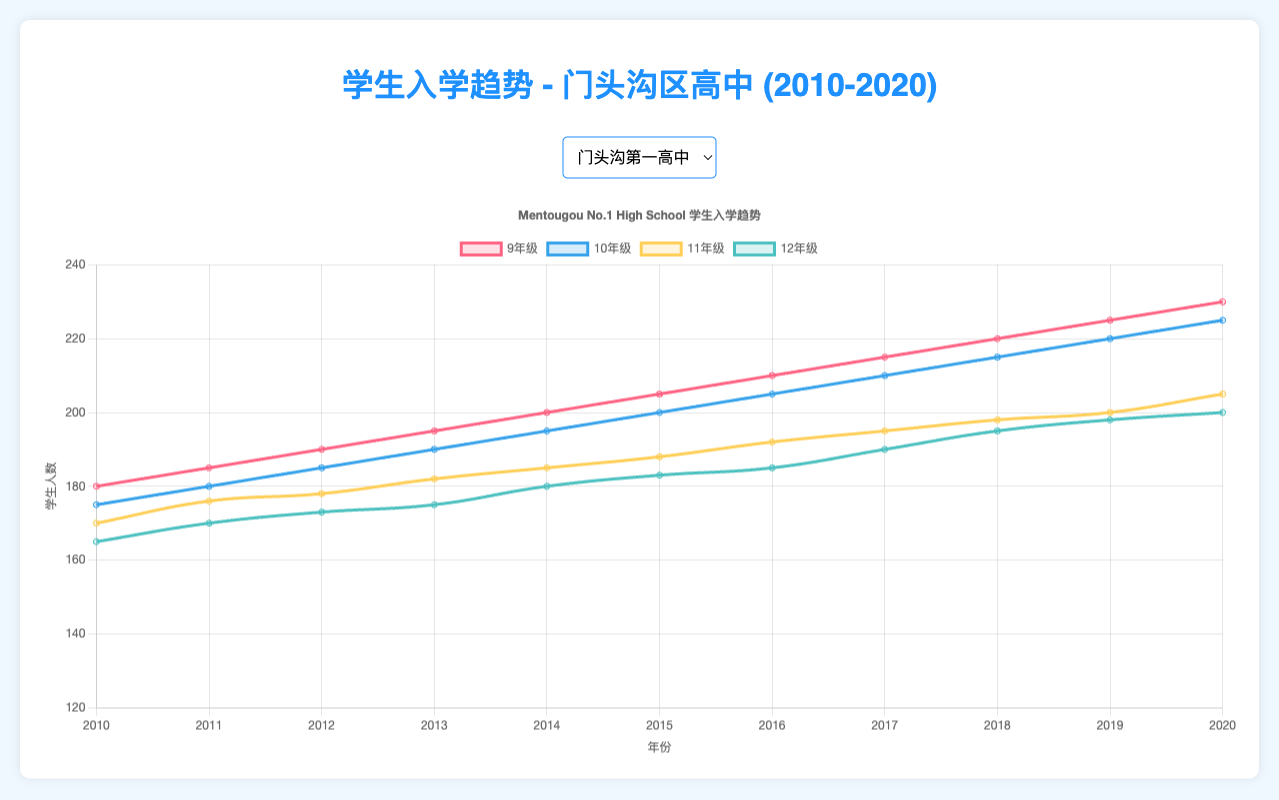What is the overall trend of 9th Grade enrollment in Mentougou No.1 High School from 2010 to 2020? The plot shows the line representing 9th Grade enrollment. The enrollment starts at 180 students in 2010 and steadily increases every year, reaching 230 students by 2020. This depicts a positive, consistent growth trend in 9th Grade enrollment over these years.
Answer: Positive growth Between Mentougou No.1 High School and Mentougou No.2 High School, which school had a higher 12th Grade enrollment in 2015? By comparing the lines for 12th Grade enrollment for both schools in 2015, Mentougou No.1 High School had 183 students, while Mentougou No.2 High School had 165 students.
Answer: Mentougou No.1 High School In which year did Mentougou Experimental High School's 11th Grade enrollment first exceed 160 students? Observing the plot, this school’s 11th Grade enrollment first exceeded 160 students in 2016 when it reached 160 and then increased further.
Answer: 2016 In 2020, what is the difference between the 9th Grade enrollment in Mentougou No.1 High School and Mentougou Experimental High School? In 2020, the two lines for 9th Grade can be compared. Mentougou No.1 High School has 230 students, and Mentougou Experimental High School has 190 students. The difference is 230 - 190 = 40 students.
Answer: 40 students What is the color used to represent the 11th Grade enrollment trend line for Mentougou No.1 High School? The color representing the 11th Grade enrollment trend for Mentougou No.1 High School is related to its line's color on the plot, which is yellow.
Answer: yellow Calculate the average 10th Grade enrollment for Mentougou No.2 High School across all years from 2010 to 2020. Summing 10th Grade enrollments from 2010 to 2020 gives: 158 + 160 + 162 + 165 + 170 + 175 + 180 + 185 + 190 + 195 + 200 = 1940. The average over these 11 years is 1940 / 11 ≈ 176.36.
Answer: 176.36 students Which grade experienced the most significant increase in enrollment numbers from 2010 to 2020 in Mentougou Experimental High School? By looking at the increase, 9th Grade enrollment went from 140 to 190, a difference of 50; 10th Grade from 138 to 185, a difference of 47; 11th Grade from 135 to 180, a difference of 45; and 12th Grade from 130 to 175, a difference of 45. The 9th Grade saw the most significant increase.
Answer: 9th Grade How did the 12th Grade enrollment trend for Mentougou No.2 High School compare to Mentougou Experimental High School from 2016 to 2020? Both trends need to be compared annually. Mentougou No.2's 12th Grade enrollment was 168 (2016), 170 (2017), 175 (2018), 178 (2019), and 180 (2020). For the Experimental, it was 155 (2016), 160 (2017), 165 (2018), 170 (2019), and 175 (2020). The trend shows consistent year-over-year increases, with Mentougou No.2 always slightly higher.
Answer: Mentougou No.2 always higher What year did Mentougou No.1 High School's 12th Grade enrollment reach 190 students? Looking at the 12th Grade enrollment line for Mentougou No.1 High School, it reached 190 students in 2017.
Answer: 2017 